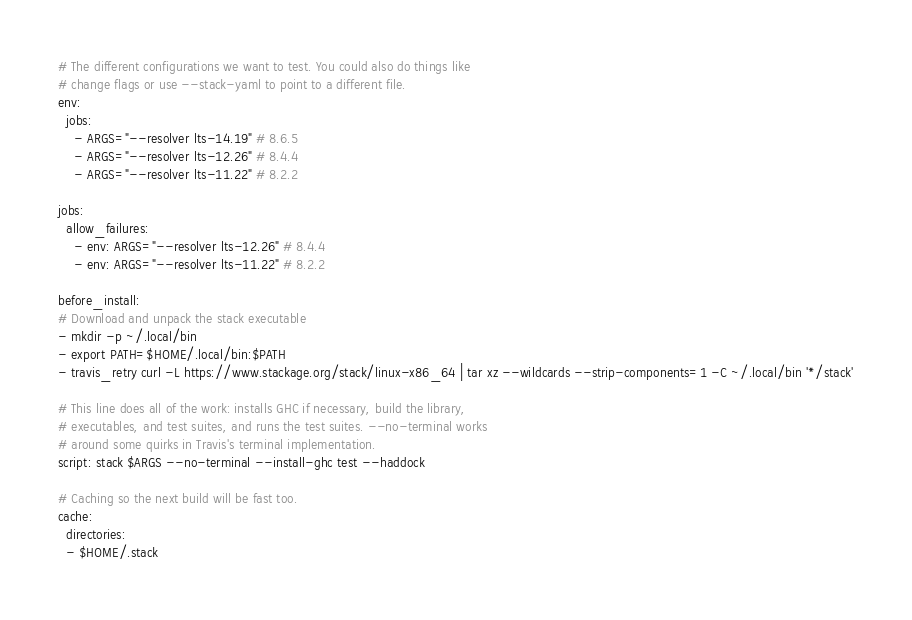Convert code to text. <code><loc_0><loc_0><loc_500><loc_500><_YAML_># The different configurations we want to test. You could also do things like
# change flags or use --stack-yaml to point to a different file.
env:
  jobs:
    - ARGS="--resolver lts-14.19" # 8.6.5
    - ARGS="--resolver lts-12.26" # 8.4.4
    - ARGS="--resolver lts-11.22" # 8.2.2

jobs:
  allow_failures:
    - env: ARGS="--resolver lts-12.26" # 8.4.4
    - env: ARGS="--resolver lts-11.22" # 8.2.2

before_install:
# Download and unpack the stack executable
- mkdir -p ~/.local/bin
- export PATH=$HOME/.local/bin:$PATH
- travis_retry curl -L https://www.stackage.org/stack/linux-x86_64 | tar xz --wildcards --strip-components=1 -C ~/.local/bin '*/stack'

# This line does all of the work: installs GHC if necessary, build the library,
# executables, and test suites, and runs the test suites. --no-terminal works
# around some quirks in Travis's terminal implementation.
script: stack $ARGS --no-terminal --install-ghc test --haddock

# Caching so the next build will be fast too.
cache:
  directories:
  - $HOME/.stack
</code> 